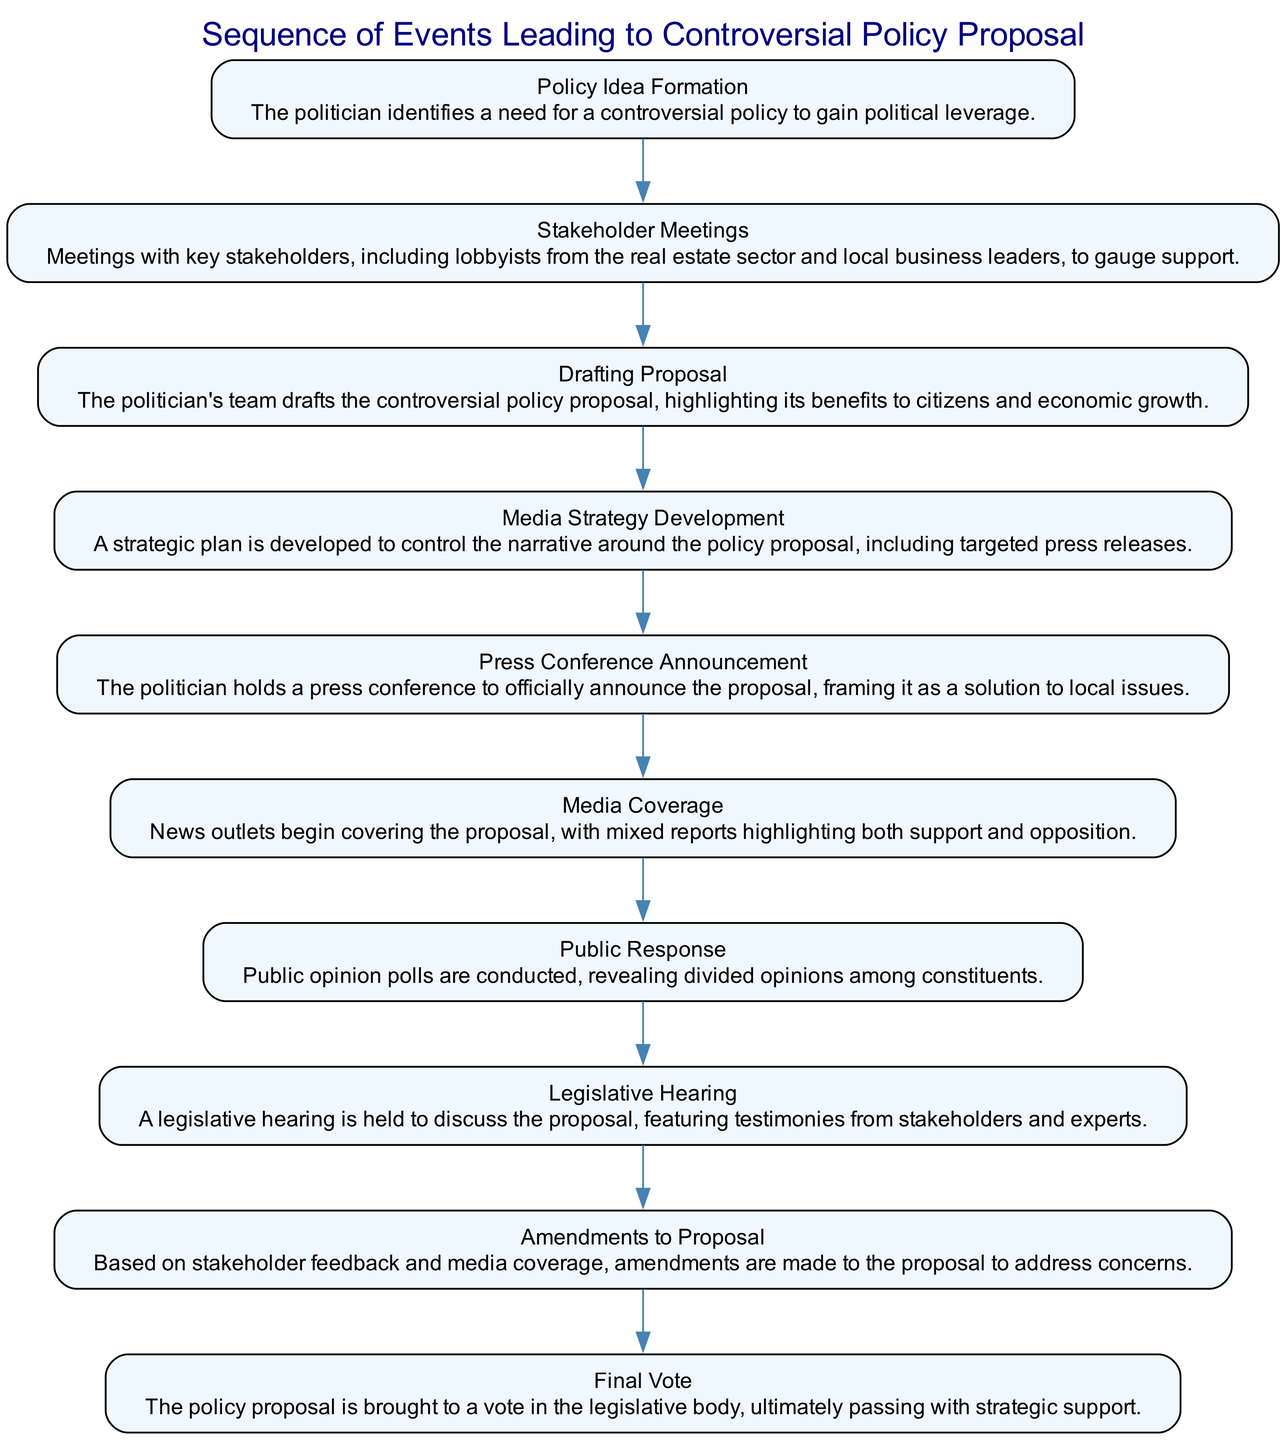What is the first event in the sequence? The diagram outlines the events in a specific order, starting from "Policy Idea Formation," which is the first event listed.
Answer: Policy Idea Formation How many events are represented in the diagram? By counting the individual events listed in the diagram, there are a total of ten events that detail the sequence leading to the controversial policy proposal.
Answer: 10 What is the fifth event in the sequence? Referring to the approximation of the fifth position of the listed events, "Press Conference Announcement" is confirmed as the fifth event in the diagram.
Answer: Press Conference Announcement Which event follows "Media Coverage"? In the sequence presented, the event that directly follows "Media Coverage" is "Public Response," indicating the next step after the media's involvement with the proposal.
Answer: Public Response What type of feedback leads to "Amendments to Proposal"? The sequence illustrates that "Stakeholder feedback" and "Media coverage" both contribute to the need for "Amendments to Proposal." This implies that the reactions from stakeholders and media prompted necessary changes.
Answer: Stakeholder feedback and Media coverage Which event is positioned before "Legislative Hearing"? The sequence shows that "Public Response" is the event that occurs immediately before "Legislative Hearing," highlighting the reaction of the public prior to the formal discussion.
Answer: Public Response What key action occurs in the "Drafting Proposal"? The diagram details that in "Drafting Proposal," the politician's team emphasizes the benefits of the controversial policy, which indicates a proactive approach to framing the proposal favorably.
Answer: Highlighting benefits to citizens and economic growth What is the result of the "Final Vote"? The sequence concludes with the event labeled "Final Vote," which results in the policy proposal passing with strategic support, indicating a successful outcome for the politician.
Answer: Passing with strategic support 